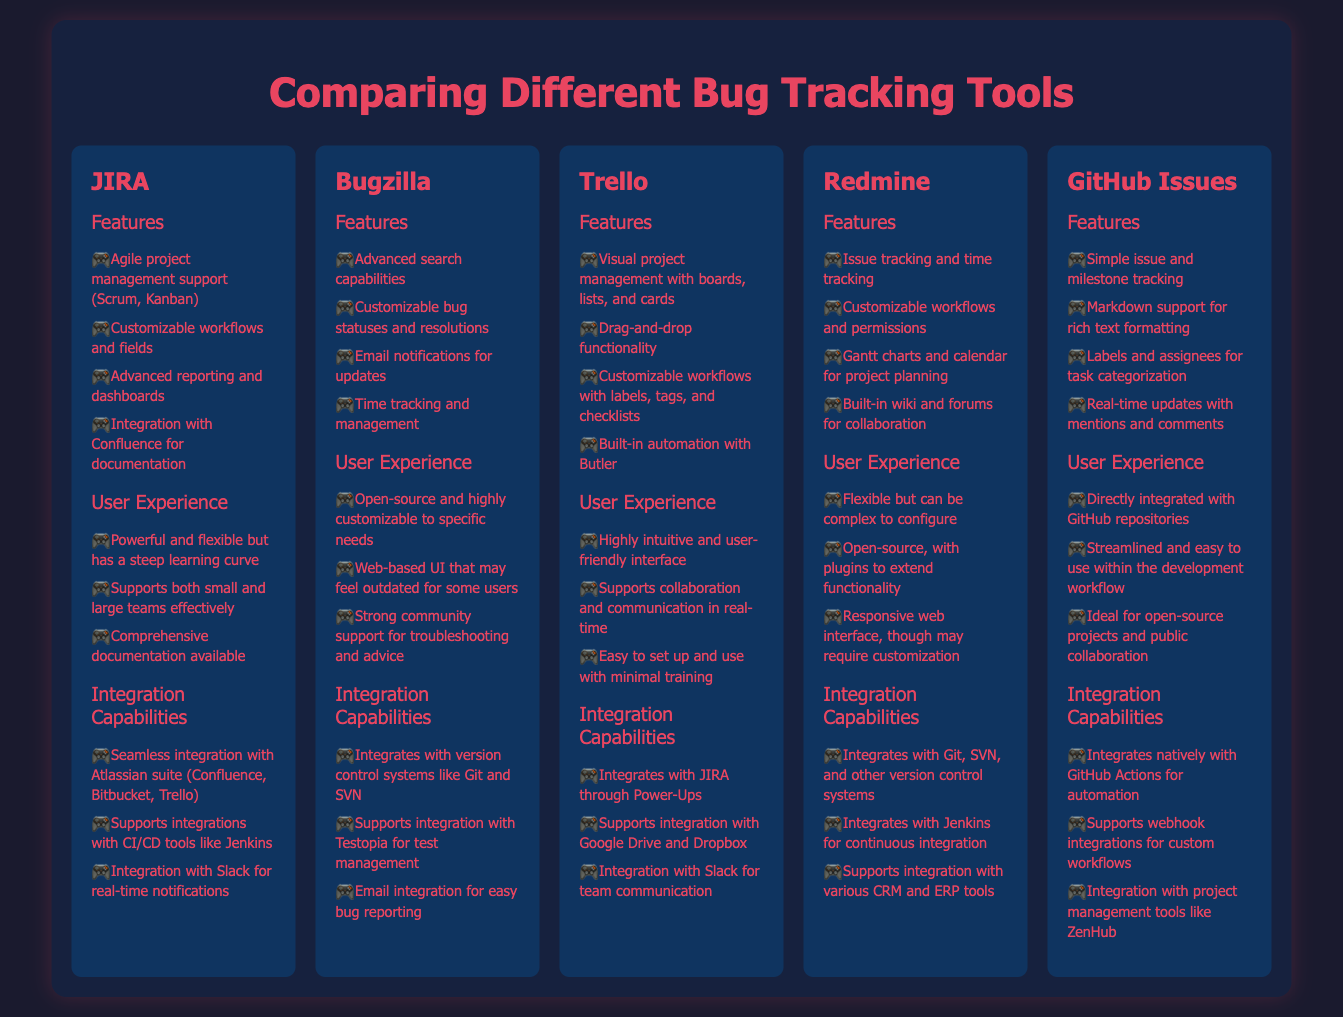What is the main title of the document? The main title is presented prominently at the top of the infographic.
Answer: Comparing Different Bug Tracking Tools What tool supports Agile project management? The document mentions specific features for each tool, including Agile project management.
Answer: JIRA Which tool is described as open-source? The document lists the tools along with their user experiences, highlighting one as open-source.
Answer: Bugzilla How many integration capabilities does Trello have listed? The document lists specific integration capabilities under each tool, which can be counted.
Answer: 3 What are the advanced reporting capabilities associated with JIRA? This question involves understanding the features section for impact on user experience.
Answer: Advanced reporting and dashboards Which tool offers time tracking as a feature? By reviewing the features section, we can identify specific offerings for tracking.
Answer: Bugzilla What is the enhanced collaboration feature of GitHub Issues? The document includes user experience aspects that pertain to collaboration among the tools.
Answer: Real-time updates with mentions and comments What is a unique feature of Trello's user experience? The user experience section outlines notable characteristics for each tool.
Answer: Highly intuitive and user-friendly interface Which tools integrate with Jenkins? The integration capabilities are enumerated for each tool, allowing for a comparison.
Answer: JIRA, Redmine 